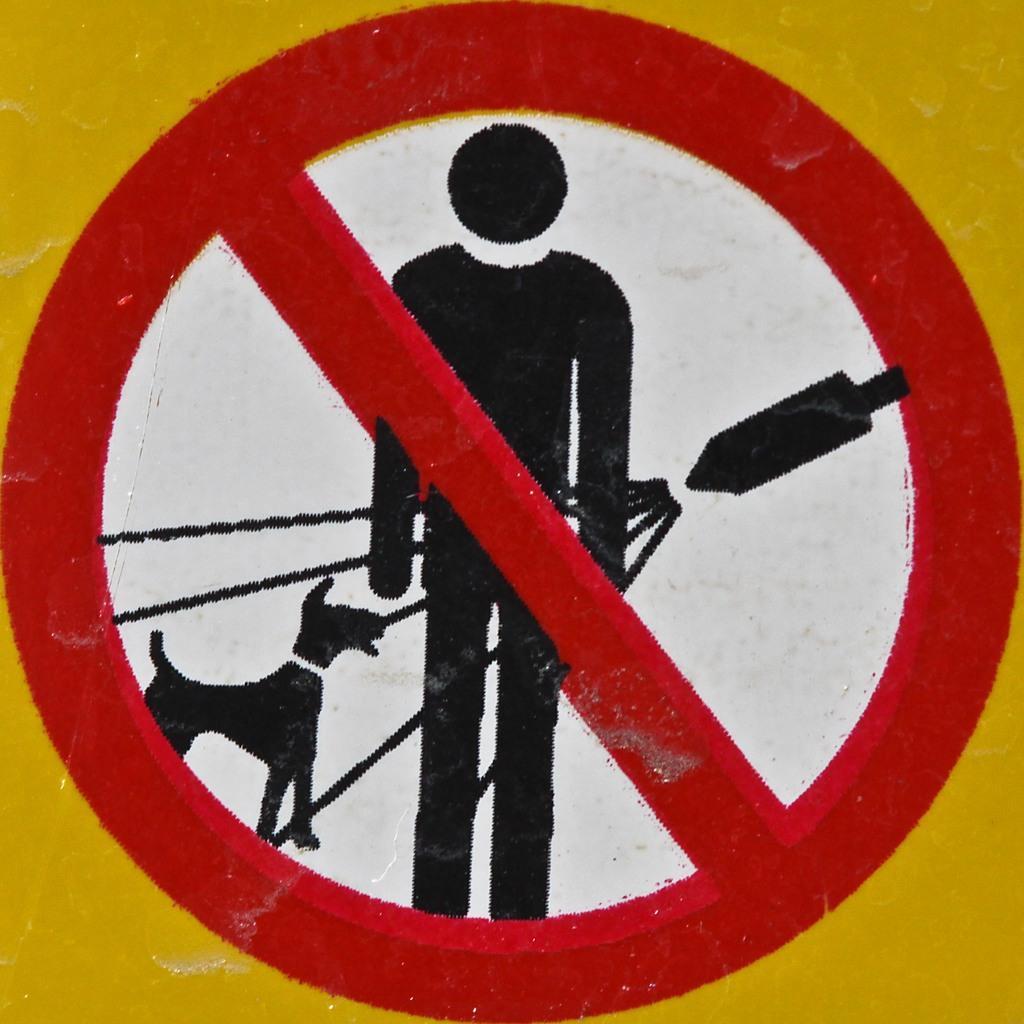Could you give a brief overview of what you see in this image? In this image we can see a sign board. 